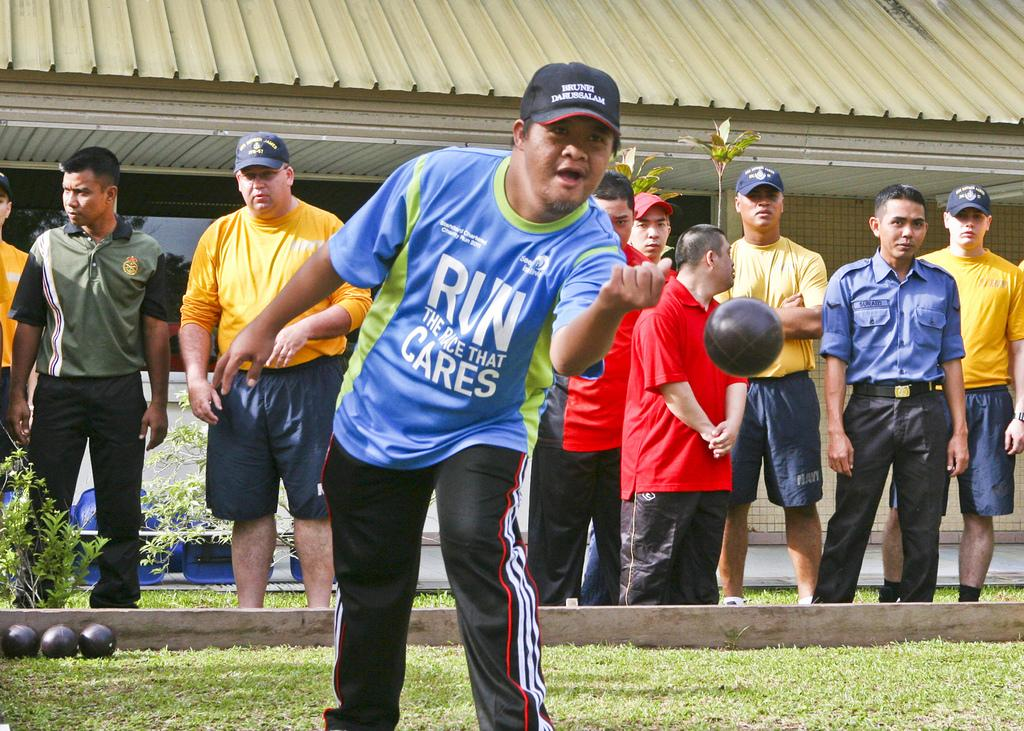<image>
Summarize the visual content of the image. a person with the word run on their shirt throwing a ball 